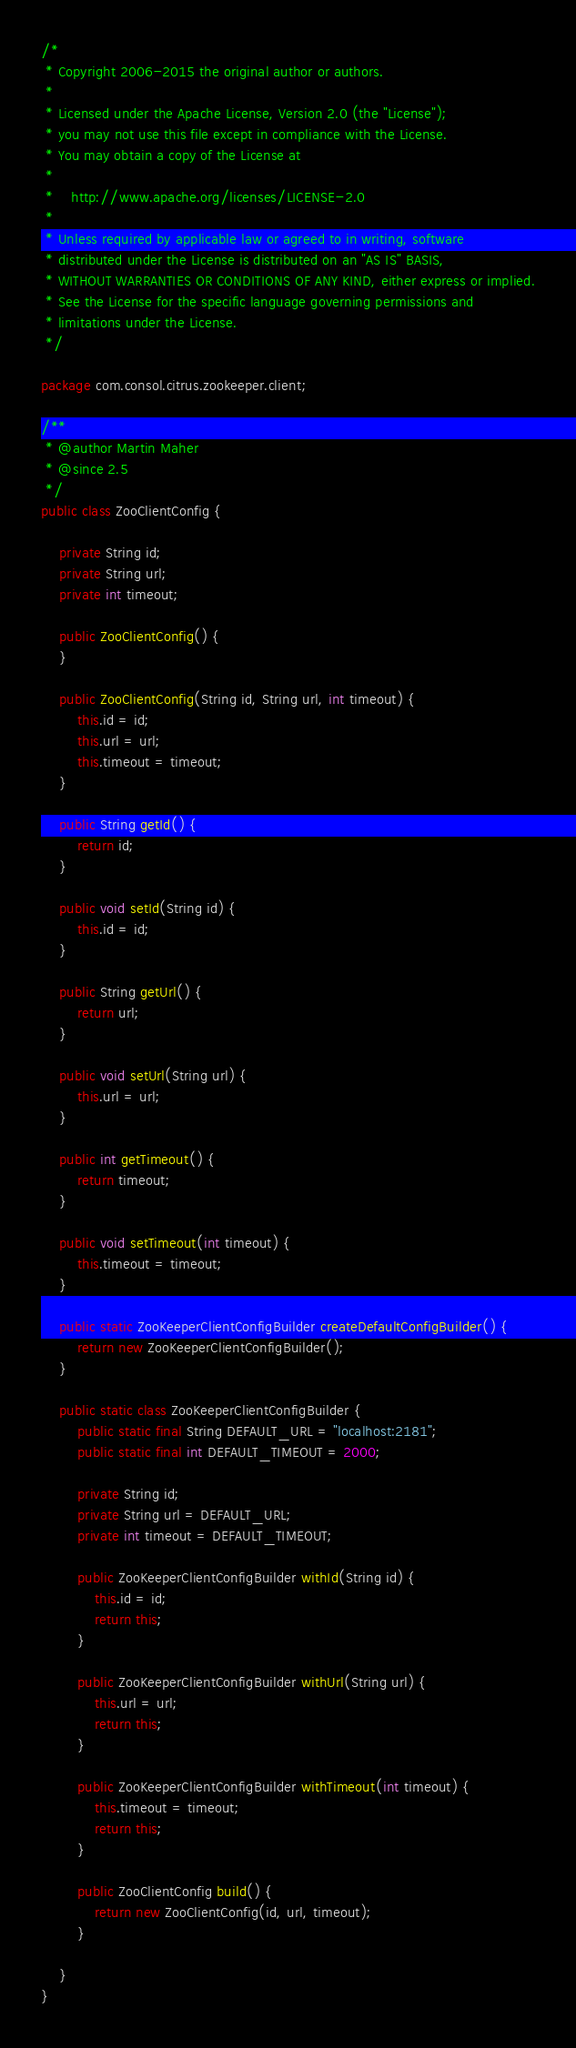<code> <loc_0><loc_0><loc_500><loc_500><_Java_>/*
 * Copyright 2006-2015 the original author or authors.
 *
 * Licensed under the Apache License, Version 2.0 (the "License");
 * you may not use this file except in compliance with the License.
 * You may obtain a copy of the License at
 *
 *    http://www.apache.org/licenses/LICENSE-2.0
 *
 * Unless required by applicable law or agreed to in writing, software
 * distributed under the License is distributed on an "AS IS" BASIS,
 * WITHOUT WARRANTIES OR CONDITIONS OF ANY KIND, either express or implied.
 * See the License for the specific language governing permissions and
 * limitations under the License.
 */

package com.consol.citrus.zookeeper.client;

/**
 * @author Martin Maher
 * @since 2.5
 */
public class ZooClientConfig {

    private String id;
    private String url;
    private int timeout;

    public ZooClientConfig() {
    }

    public ZooClientConfig(String id, String url, int timeout) {
        this.id = id;
        this.url = url;
        this.timeout = timeout;
    }

    public String getId() {
        return id;
    }

    public void setId(String id) {
        this.id = id;
    }

    public String getUrl() {
        return url;
    }

    public void setUrl(String url) {
        this.url = url;
    }

    public int getTimeout() {
        return timeout;
    }

    public void setTimeout(int timeout) {
        this.timeout = timeout;
    }

    public static ZooKeeperClientConfigBuilder createDefaultConfigBuilder() {
        return new ZooKeeperClientConfigBuilder();
    }

    public static class ZooKeeperClientConfigBuilder {
        public static final String DEFAULT_URL = "localhost:2181";
        public static final int DEFAULT_TIMEOUT = 2000;

        private String id;
        private String url = DEFAULT_URL;
        private int timeout = DEFAULT_TIMEOUT;

        public ZooKeeperClientConfigBuilder withId(String id) {
            this.id = id;
            return this;
        }

        public ZooKeeperClientConfigBuilder withUrl(String url) {
            this.url = url;
            return this;
        }

        public ZooKeeperClientConfigBuilder withTimeout(int timeout) {
            this.timeout = timeout;
            return this;
        }

        public ZooClientConfig build() {
            return new ZooClientConfig(id, url, timeout);
        }

    }
}
</code> 